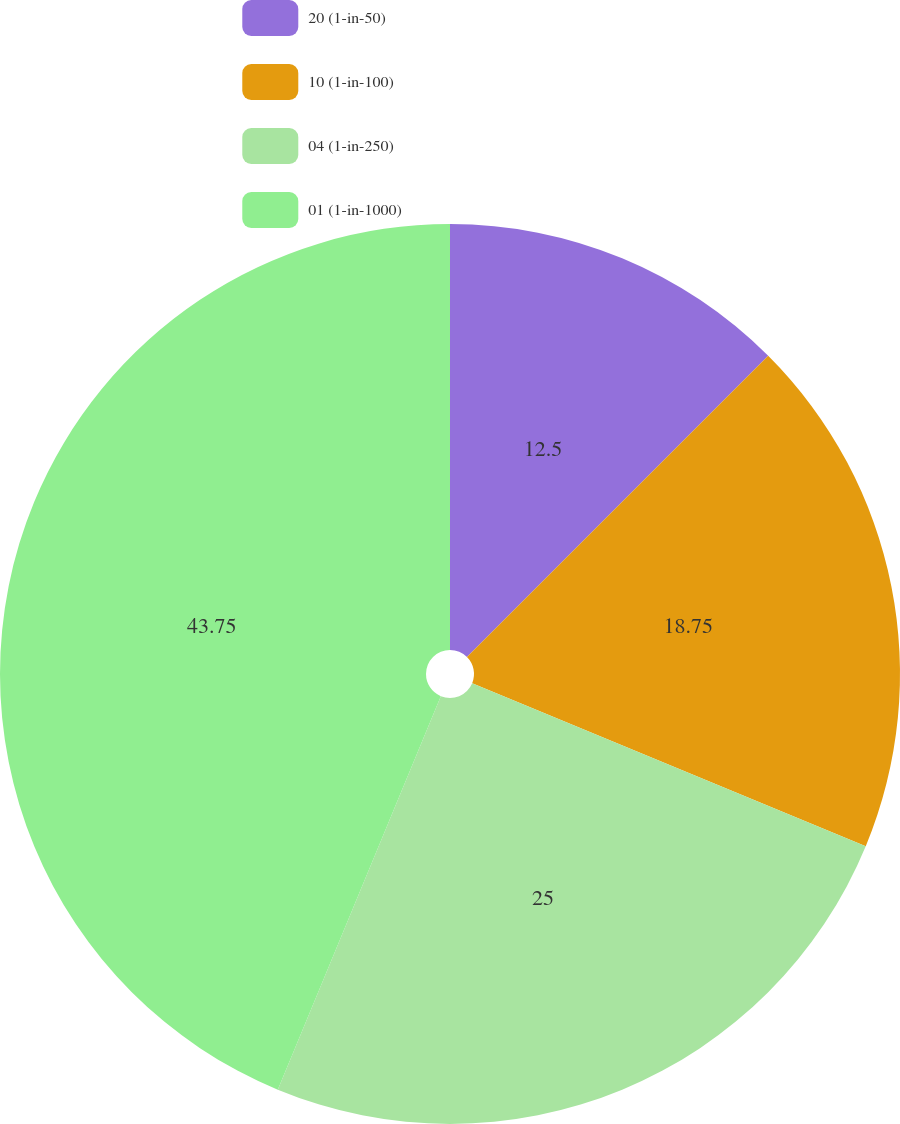Convert chart to OTSL. <chart><loc_0><loc_0><loc_500><loc_500><pie_chart><fcel>20 (1-in-50)<fcel>10 (1-in-100)<fcel>04 (1-in-250)<fcel>01 (1-in-1000)<nl><fcel>12.5%<fcel>18.75%<fcel>25.0%<fcel>43.75%<nl></chart> 